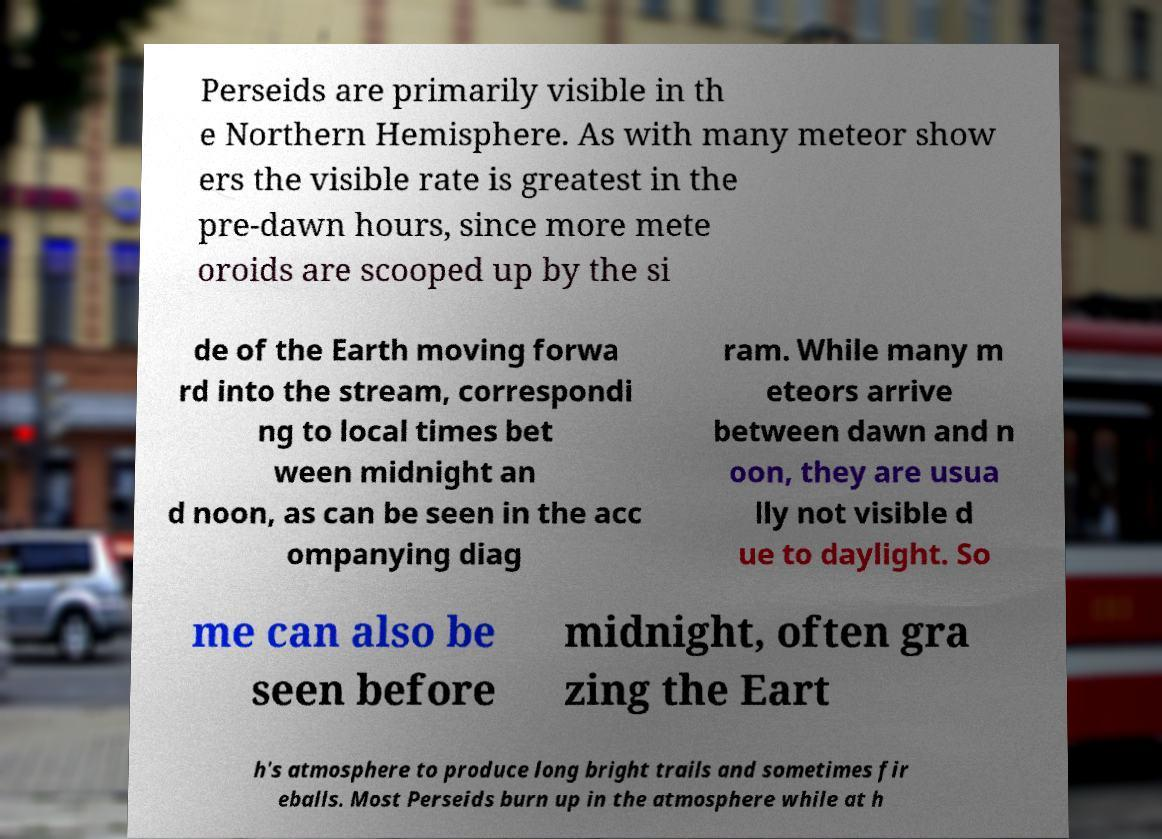What messages or text are displayed in this image? I need them in a readable, typed format. Perseids are primarily visible in th e Northern Hemisphere. As with many meteor show ers the visible rate is greatest in the pre-dawn hours, since more mete oroids are scooped up by the si de of the Earth moving forwa rd into the stream, correspondi ng to local times bet ween midnight an d noon, as can be seen in the acc ompanying diag ram. While many m eteors arrive between dawn and n oon, they are usua lly not visible d ue to daylight. So me can also be seen before midnight, often gra zing the Eart h's atmosphere to produce long bright trails and sometimes fir eballs. Most Perseids burn up in the atmosphere while at h 